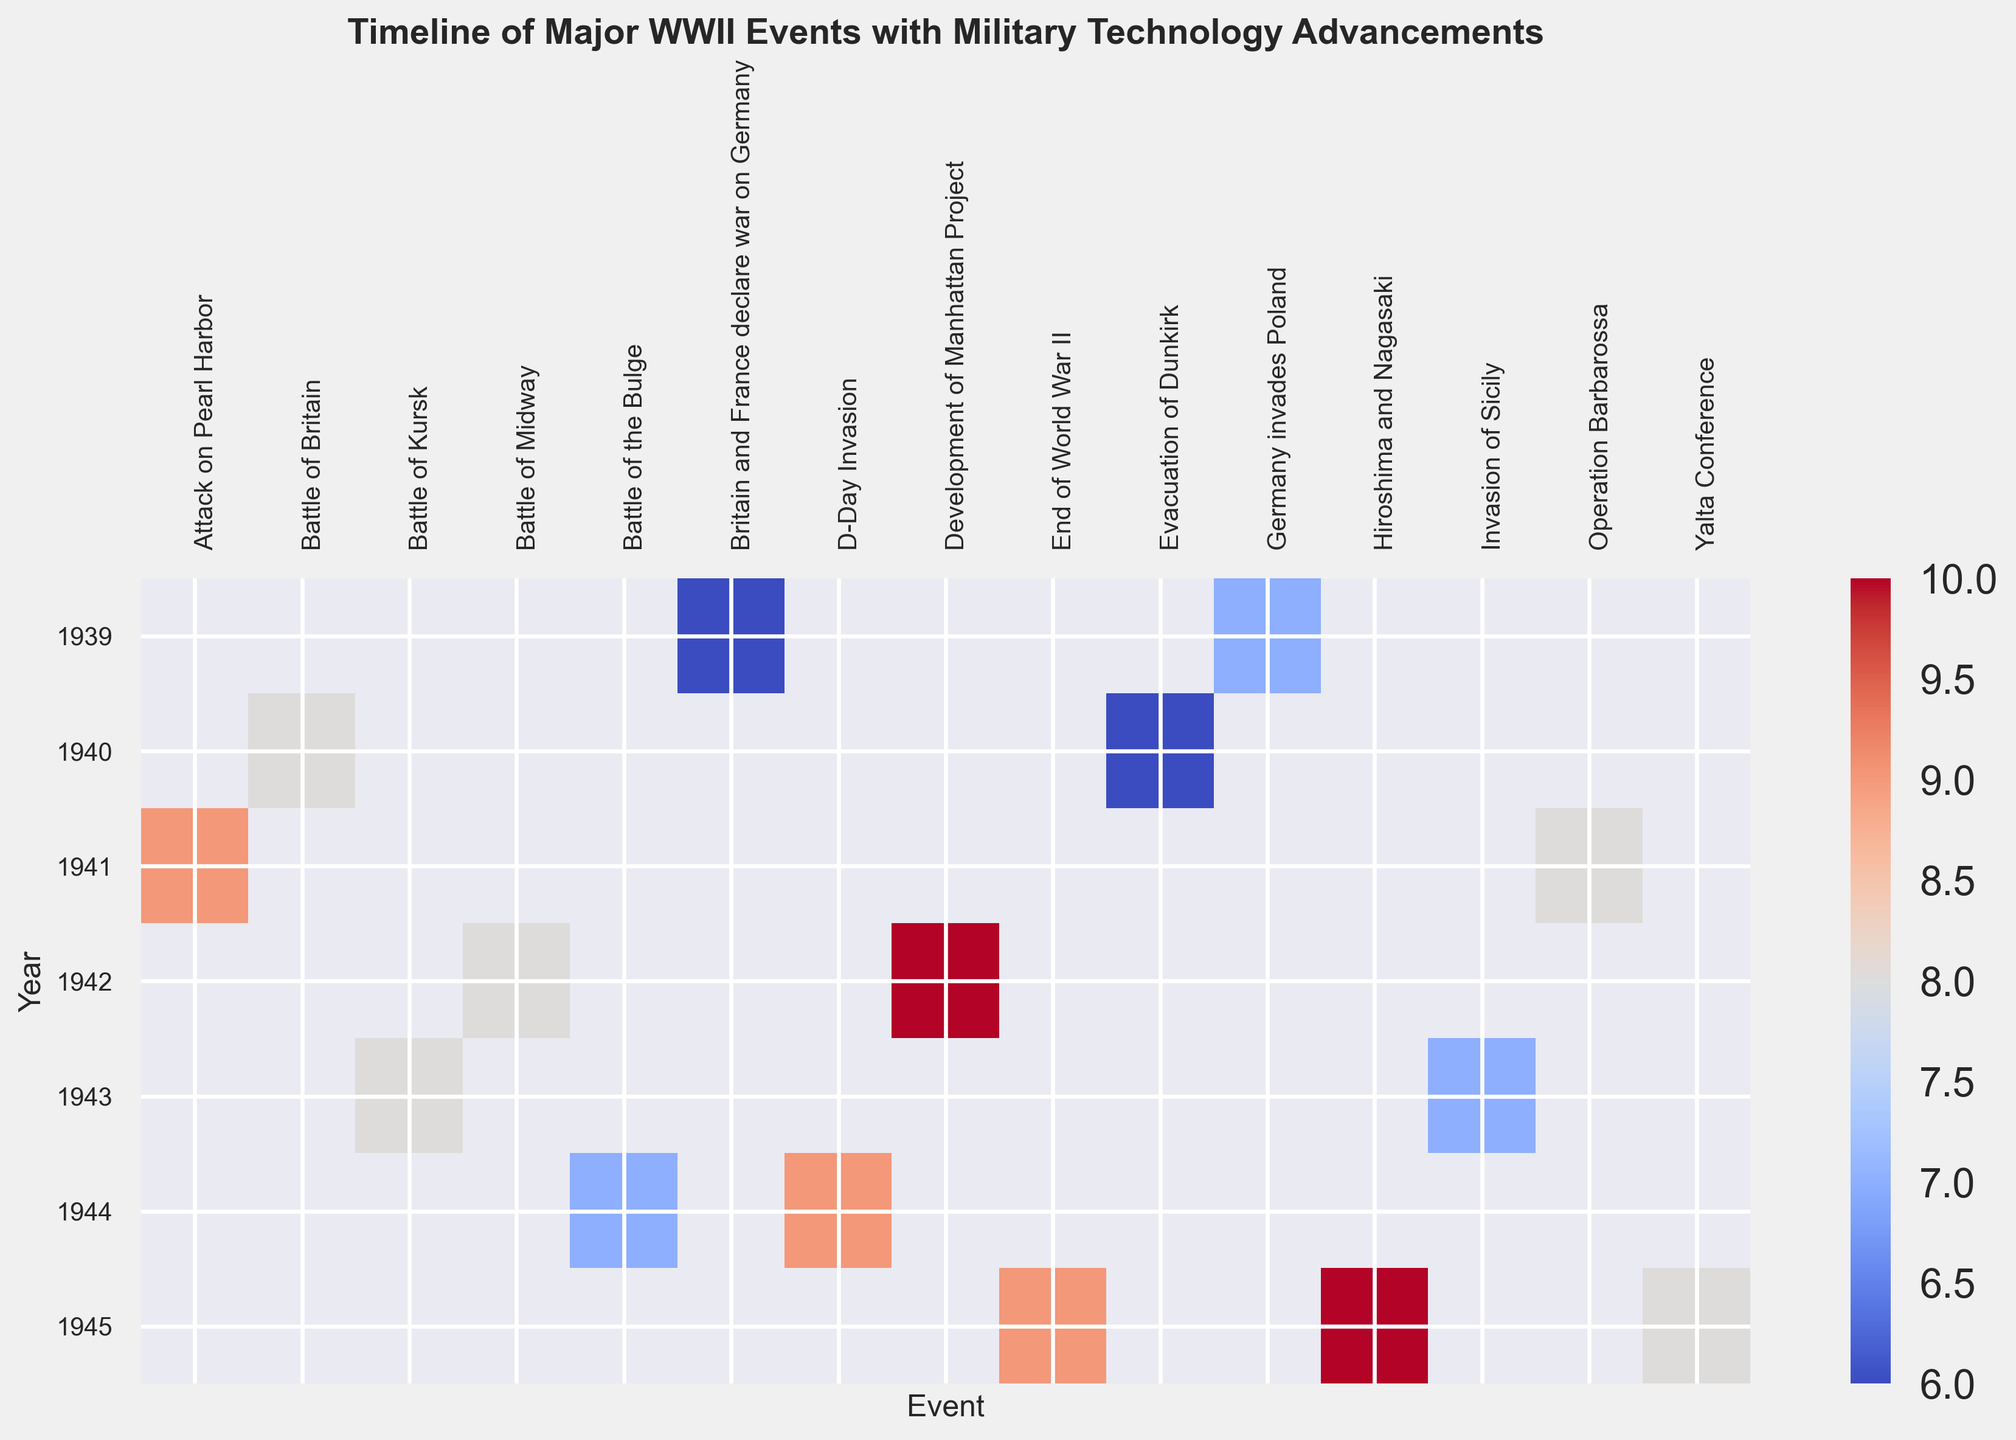Which event in 1945 has the highest significance score, and what is the score? To determine this, examine the heatmap for the year 1945 and identify the event with the highest score based on color intensity. The darkest or most intense color represents the highest score. Check the color bar for exact scores.
Answer: Hiroshima and Nagasaki, 10 In which year did the significance score for "Aircraft carrier utilization" reach 9? Locate "Aircraft carrier utilization" on the heatmap and note the year associated with the darkest hue, referring to the color bar to confirm that the score is 9.
Answer: 1941 Are there any events in 1942 with a significance score of 8? If so, what are they? Check the heatmap for the row corresponding to 1942 and identify any events with a color that matches the score of 8 using the color bar as reference.
Answer: Battle of Midway Compare the significance scores between "Development of radar" and "Development of Manhattan Project". Which one is higher and by how much? Locate both events on the heatmap and refer to their significance scores. "Development of radar" is in 1940, and "Development of Manhattan Project" is in 1942. Subtract the lower score from the higher one.
Answer: Manhattan Project is higher by 4 (10 - 6) How did the significance score for "Blitzkrieg strategy" in 1939 compare with "Innovations in tank warfare" in 1943? Check the heatmap for the years 1939 and 1943 for the respective events and compare their scores based on the color intensity.
Answer: Both are equal, 8 What's the average significance score of all events that occurred in 1944? Identify all the events for 1944 on the heatmap and sum up their scores. Divide this sum by the total number of events in 1944.
Answer: (9 + 7) / 2 = 8 Which event has the lowest significance score in 1939, and what is the score? Look at the heatmap for the events in 1939 and find the one with the least intense color, using the color bar to determine the exact score.
Answer: Britain and France declare war on Germany, 6 How many events have a significance score equal to 7? Scan the entire heatmap and count the occurrences of the color representing a score of 7. Verify against the color bar.
Answer: 3 events List the events in chronological order that had a significance score of 8. Check the heatmap for events marked with the color corresponding to a score of 8 and list them according to the year they happened.
Answer: Battle of Britain in 1940, Operation Barbarossa in 1941, Battle of Midway in 1942, Battle of Kursk in 1943, Yalta Conference in 1945 